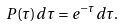<formula> <loc_0><loc_0><loc_500><loc_500>P ( \tau ) d \tau = e ^ { - \tau } d \tau .</formula> 